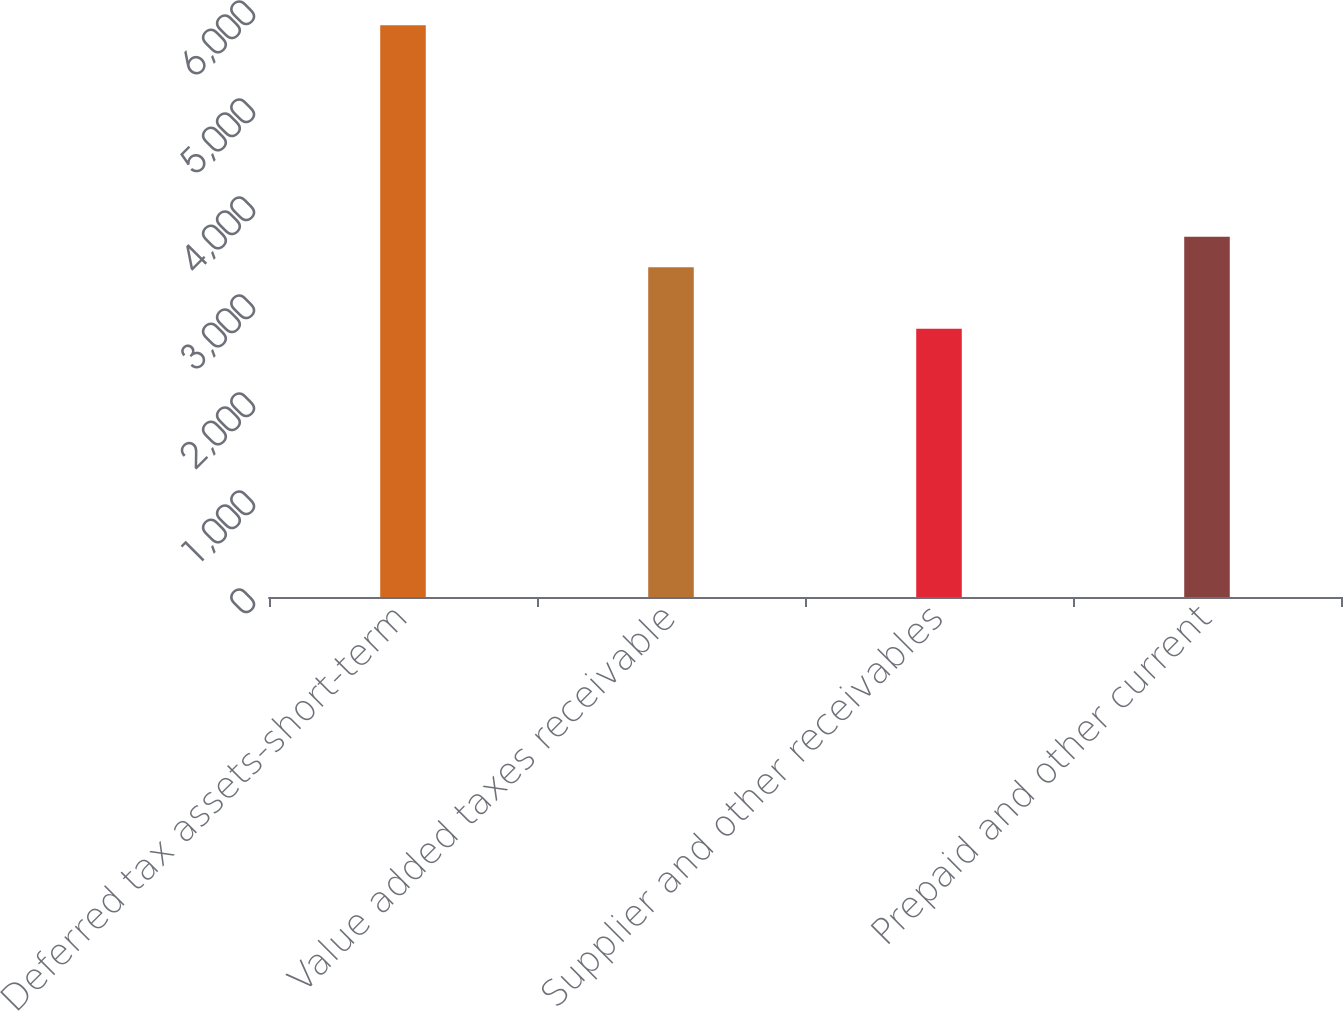Convert chart to OTSL. <chart><loc_0><loc_0><loc_500><loc_500><bar_chart><fcel>Deferred tax assets-short-term<fcel>Value added taxes receivable<fcel>Supplier and other receivables<fcel>Prepaid and other current<nl><fcel>5833<fcel>3366<fcel>2737<fcel>3675.6<nl></chart> 